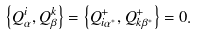Convert formula to latex. <formula><loc_0><loc_0><loc_500><loc_500>\left \{ Q _ { \alpha } ^ { i } , Q _ { \beta } ^ { k } \right \} = \left \{ Q _ { i \alpha ^ { * } } ^ { + } , Q _ { k \beta ^ { * } } ^ { + } \right \} = 0 .</formula> 